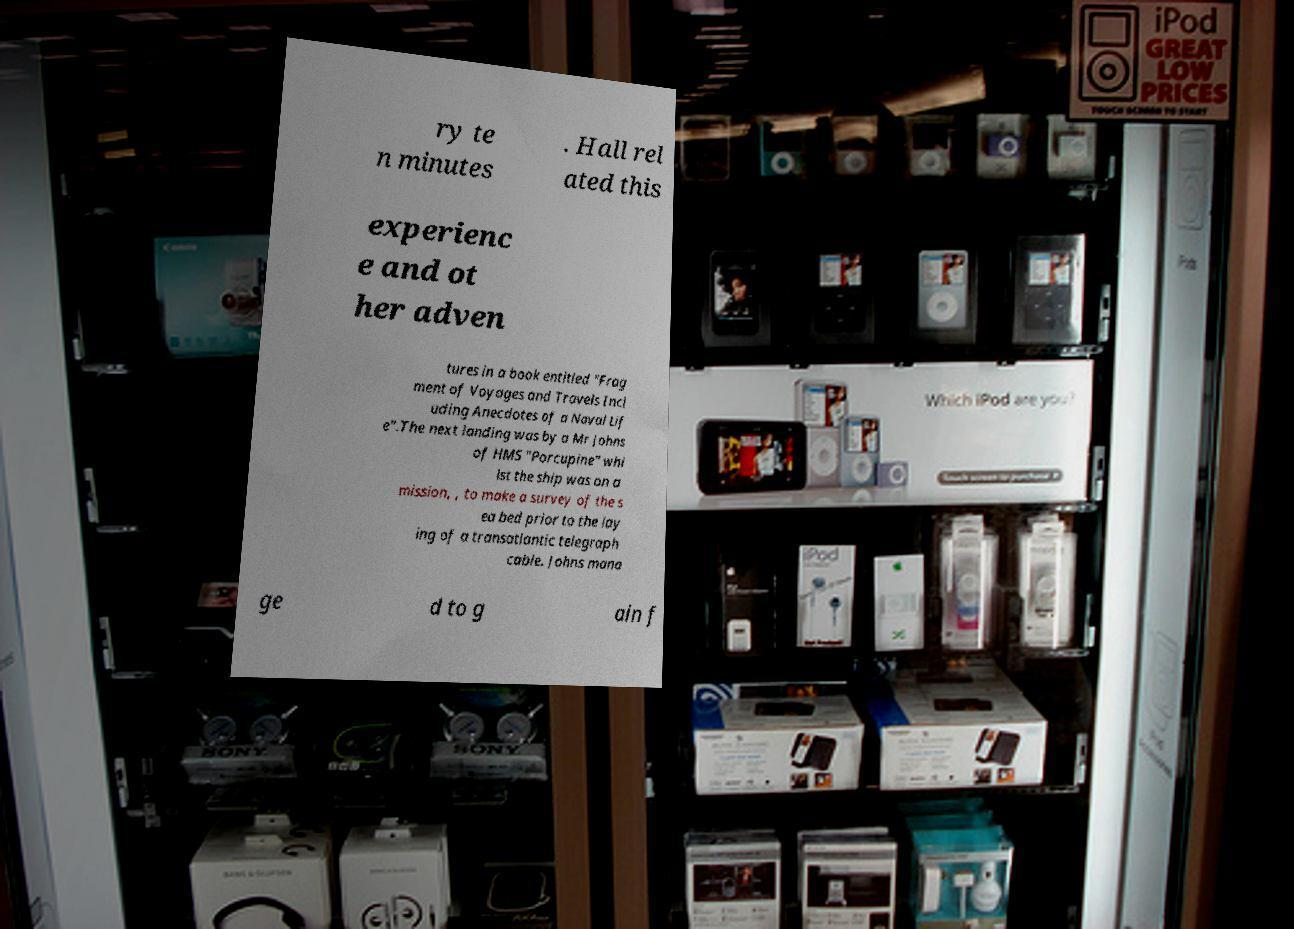Can you accurately transcribe the text from the provided image for me? ry te n minutes . Hall rel ated this experienc e and ot her adven tures in a book entitled "Frag ment of Voyages and Travels Incl uding Anecdotes of a Naval Lif e".The next landing was by a Mr Johns of HMS "Porcupine" whi lst the ship was on a mission, , to make a survey of the s ea bed prior to the lay ing of a transatlantic telegraph cable. Johns mana ge d to g ain f 